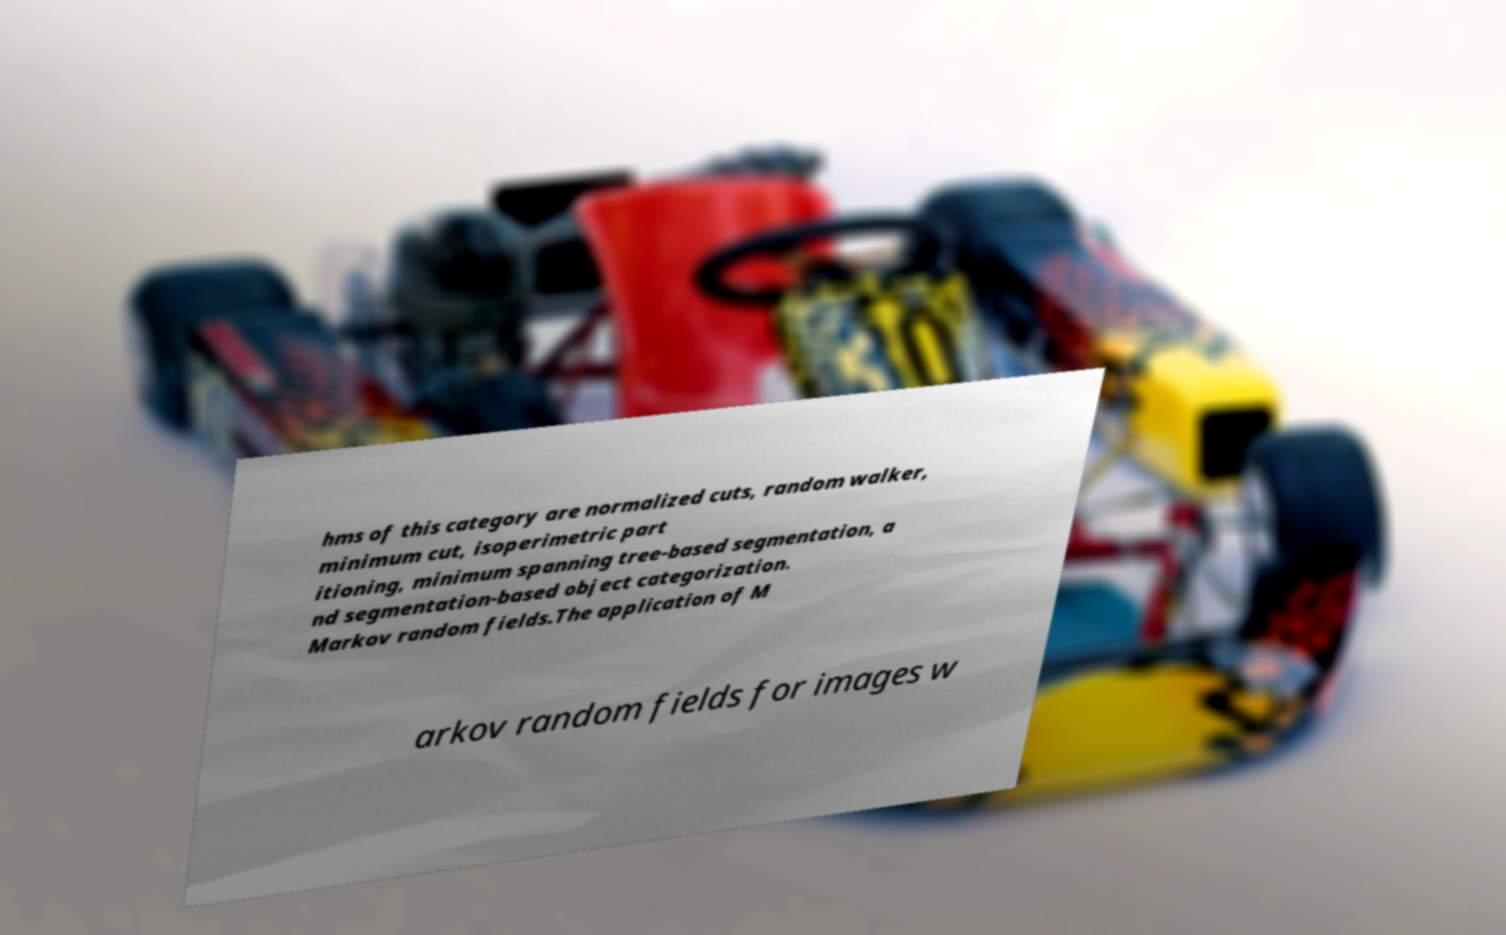What messages or text are displayed in this image? I need them in a readable, typed format. hms of this category are normalized cuts, random walker, minimum cut, isoperimetric part itioning, minimum spanning tree-based segmentation, a nd segmentation-based object categorization. Markov random fields.The application of M arkov random fields for images w 